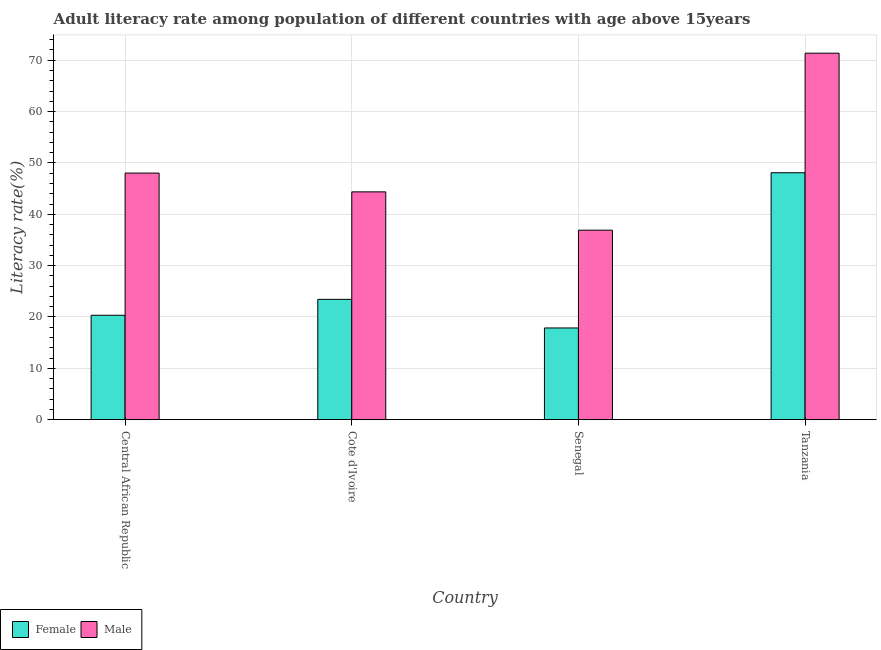How many groups of bars are there?
Provide a succinct answer. 4. Are the number of bars on each tick of the X-axis equal?
Offer a terse response. Yes. How many bars are there on the 1st tick from the left?
Ensure brevity in your answer.  2. How many bars are there on the 2nd tick from the right?
Your answer should be very brief. 2. What is the label of the 4th group of bars from the left?
Offer a very short reply. Tanzania. What is the female adult literacy rate in Cote d'Ivoire?
Make the answer very short. 23.43. Across all countries, what is the maximum male adult literacy rate?
Give a very brief answer. 71.37. Across all countries, what is the minimum female adult literacy rate?
Your response must be concise. 17.86. In which country was the male adult literacy rate maximum?
Your answer should be very brief. Tanzania. In which country was the female adult literacy rate minimum?
Provide a succinct answer. Senegal. What is the total male adult literacy rate in the graph?
Your response must be concise. 200.65. What is the difference between the female adult literacy rate in Cote d'Ivoire and that in Tanzania?
Your response must be concise. -24.65. What is the difference between the female adult literacy rate in Cote d'Ivoire and the male adult literacy rate in Tanzania?
Make the answer very short. -47.93. What is the average male adult literacy rate per country?
Make the answer very short. 50.16. What is the difference between the male adult literacy rate and female adult literacy rate in Tanzania?
Make the answer very short. 23.28. What is the ratio of the female adult literacy rate in Cote d'Ivoire to that in Senegal?
Your answer should be very brief. 1.31. What is the difference between the highest and the second highest male adult literacy rate?
Offer a terse response. 23.35. What is the difference between the highest and the lowest male adult literacy rate?
Provide a succinct answer. 34.46. Is the sum of the female adult literacy rate in Cote d'Ivoire and Senegal greater than the maximum male adult literacy rate across all countries?
Your answer should be very brief. No. What does the 1st bar from the left in Central African Republic represents?
Provide a short and direct response. Female. How many countries are there in the graph?
Your answer should be compact. 4. What is the difference between two consecutive major ticks on the Y-axis?
Offer a very short reply. 10. Are the values on the major ticks of Y-axis written in scientific E-notation?
Offer a very short reply. No. Does the graph contain grids?
Provide a succinct answer. Yes. How are the legend labels stacked?
Your answer should be very brief. Horizontal. What is the title of the graph?
Your answer should be very brief. Adult literacy rate among population of different countries with age above 15years. Does "Personal remittances" appear as one of the legend labels in the graph?
Give a very brief answer. No. What is the label or title of the X-axis?
Your response must be concise. Country. What is the label or title of the Y-axis?
Keep it short and to the point. Literacy rate(%). What is the Literacy rate(%) in Female in Central African Republic?
Provide a succinct answer. 20.34. What is the Literacy rate(%) of Male in Central African Republic?
Provide a succinct answer. 48.02. What is the Literacy rate(%) of Female in Cote d'Ivoire?
Give a very brief answer. 23.43. What is the Literacy rate(%) in Male in Cote d'Ivoire?
Offer a very short reply. 44.36. What is the Literacy rate(%) of Female in Senegal?
Give a very brief answer. 17.86. What is the Literacy rate(%) of Male in Senegal?
Provide a short and direct response. 36.9. What is the Literacy rate(%) in Female in Tanzania?
Keep it short and to the point. 48.09. What is the Literacy rate(%) in Male in Tanzania?
Provide a succinct answer. 71.37. Across all countries, what is the maximum Literacy rate(%) in Female?
Your response must be concise. 48.09. Across all countries, what is the maximum Literacy rate(%) of Male?
Your answer should be compact. 71.37. Across all countries, what is the minimum Literacy rate(%) in Female?
Your response must be concise. 17.86. Across all countries, what is the minimum Literacy rate(%) in Male?
Your response must be concise. 36.9. What is the total Literacy rate(%) in Female in the graph?
Provide a succinct answer. 109.72. What is the total Literacy rate(%) of Male in the graph?
Your answer should be very brief. 200.65. What is the difference between the Literacy rate(%) of Female in Central African Republic and that in Cote d'Ivoire?
Your answer should be compact. -3.1. What is the difference between the Literacy rate(%) of Male in Central African Republic and that in Cote d'Ivoire?
Your answer should be very brief. 3.66. What is the difference between the Literacy rate(%) in Female in Central African Republic and that in Senegal?
Your answer should be compact. 2.47. What is the difference between the Literacy rate(%) in Male in Central African Republic and that in Senegal?
Offer a very short reply. 11.12. What is the difference between the Literacy rate(%) of Female in Central African Republic and that in Tanzania?
Make the answer very short. -27.75. What is the difference between the Literacy rate(%) in Male in Central African Republic and that in Tanzania?
Offer a very short reply. -23.35. What is the difference between the Literacy rate(%) of Female in Cote d'Ivoire and that in Senegal?
Provide a succinct answer. 5.57. What is the difference between the Literacy rate(%) of Male in Cote d'Ivoire and that in Senegal?
Your response must be concise. 7.46. What is the difference between the Literacy rate(%) in Female in Cote d'Ivoire and that in Tanzania?
Your answer should be very brief. -24.65. What is the difference between the Literacy rate(%) of Male in Cote d'Ivoire and that in Tanzania?
Your answer should be compact. -27. What is the difference between the Literacy rate(%) of Female in Senegal and that in Tanzania?
Give a very brief answer. -30.22. What is the difference between the Literacy rate(%) in Male in Senegal and that in Tanzania?
Ensure brevity in your answer.  -34.46. What is the difference between the Literacy rate(%) of Female in Central African Republic and the Literacy rate(%) of Male in Cote d'Ivoire?
Offer a very short reply. -24.03. What is the difference between the Literacy rate(%) of Female in Central African Republic and the Literacy rate(%) of Male in Senegal?
Offer a very short reply. -16.57. What is the difference between the Literacy rate(%) of Female in Central African Republic and the Literacy rate(%) of Male in Tanzania?
Provide a succinct answer. -51.03. What is the difference between the Literacy rate(%) in Female in Cote d'Ivoire and the Literacy rate(%) in Male in Senegal?
Your response must be concise. -13.47. What is the difference between the Literacy rate(%) of Female in Cote d'Ivoire and the Literacy rate(%) of Male in Tanzania?
Give a very brief answer. -47.93. What is the difference between the Literacy rate(%) in Female in Senegal and the Literacy rate(%) in Male in Tanzania?
Provide a short and direct response. -53.5. What is the average Literacy rate(%) in Female per country?
Your answer should be very brief. 27.43. What is the average Literacy rate(%) in Male per country?
Offer a very short reply. 50.16. What is the difference between the Literacy rate(%) in Female and Literacy rate(%) in Male in Central African Republic?
Make the answer very short. -27.68. What is the difference between the Literacy rate(%) of Female and Literacy rate(%) of Male in Cote d'Ivoire?
Offer a very short reply. -20.93. What is the difference between the Literacy rate(%) in Female and Literacy rate(%) in Male in Senegal?
Your answer should be compact. -19.04. What is the difference between the Literacy rate(%) of Female and Literacy rate(%) of Male in Tanzania?
Ensure brevity in your answer.  -23.28. What is the ratio of the Literacy rate(%) in Female in Central African Republic to that in Cote d'Ivoire?
Ensure brevity in your answer.  0.87. What is the ratio of the Literacy rate(%) in Male in Central African Republic to that in Cote d'Ivoire?
Ensure brevity in your answer.  1.08. What is the ratio of the Literacy rate(%) of Female in Central African Republic to that in Senegal?
Offer a terse response. 1.14. What is the ratio of the Literacy rate(%) of Male in Central African Republic to that in Senegal?
Keep it short and to the point. 1.3. What is the ratio of the Literacy rate(%) in Female in Central African Republic to that in Tanzania?
Offer a terse response. 0.42. What is the ratio of the Literacy rate(%) in Male in Central African Republic to that in Tanzania?
Give a very brief answer. 0.67. What is the ratio of the Literacy rate(%) of Female in Cote d'Ivoire to that in Senegal?
Ensure brevity in your answer.  1.31. What is the ratio of the Literacy rate(%) of Male in Cote d'Ivoire to that in Senegal?
Your answer should be compact. 1.2. What is the ratio of the Literacy rate(%) of Female in Cote d'Ivoire to that in Tanzania?
Keep it short and to the point. 0.49. What is the ratio of the Literacy rate(%) of Male in Cote d'Ivoire to that in Tanzania?
Ensure brevity in your answer.  0.62. What is the ratio of the Literacy rate(%) of Female in Senegal to that in Tanzania?
Your response must be concise. 0.37. What is the ratio of the Literacy rate(%) in Male in Senegal to that in Tanzania?
Ensure brevity in your answer.  0.52. What is the difference between the highest and the second highest Literacy rate(%) in Female?
Your response must be concise. 24.65. What is the difference between the highest and the second highest Literacy rate(%) of Male?
Make the answer very short. 23.35. What is the difference between the highest and the lowest Literacy rate(%) of Female?
Your answer should be very brief. 30.22. What is the difference between the highest and the lowest Literacy rate(%) in Male?
Your answer should be very brief. 34.46. 